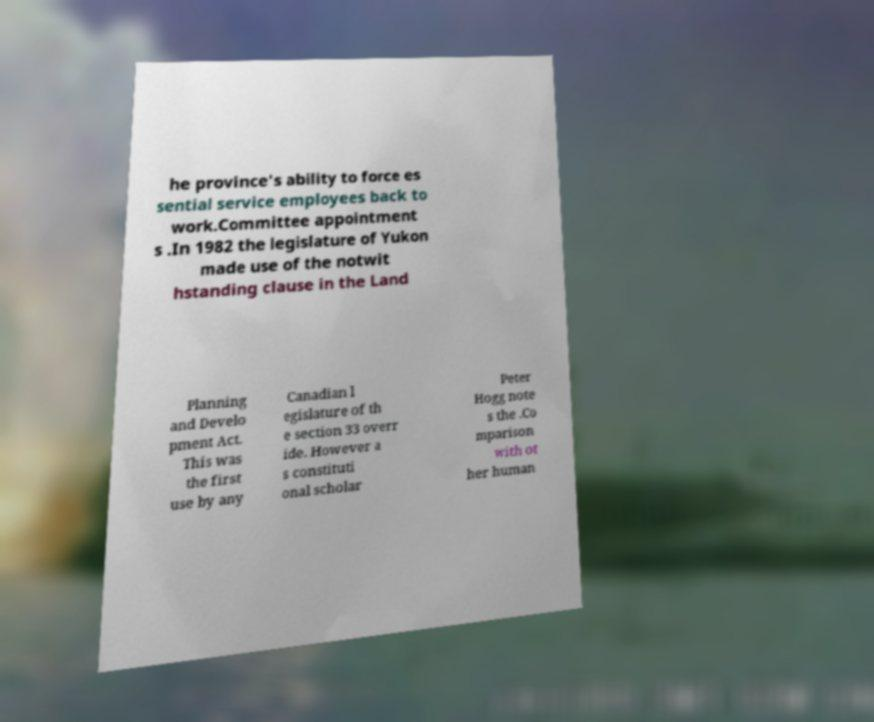There's text embedded in this image that I need extracted. Can you transcribe it verbatim? he province's ability to force es sential service employees back to work.Committee appointment s .In 1982 the legislature of Yukon made use of the notwit hstanding clause in the Land Planning and Develo pment Act. This was the first use by any Canadian l egislature of th e section 33 overr ide. However a s constituti onal scholar Peter Hogg note s the .Co mparison with ot her human 